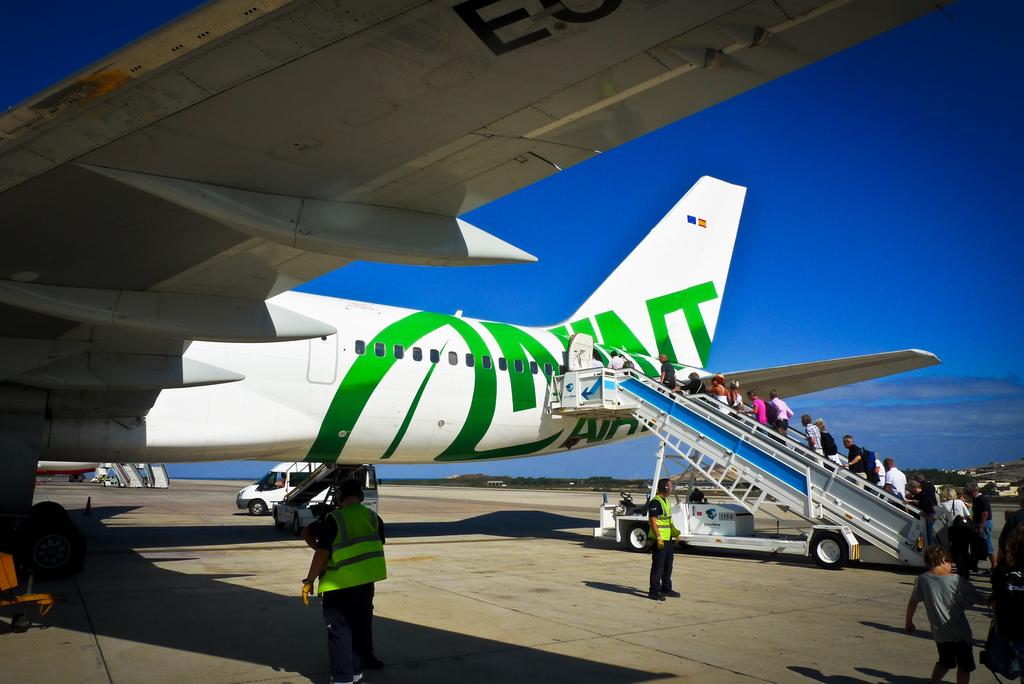Which single letter is almost fully visible underneath the wing of the plane?
Provide a succinct answer. E. 